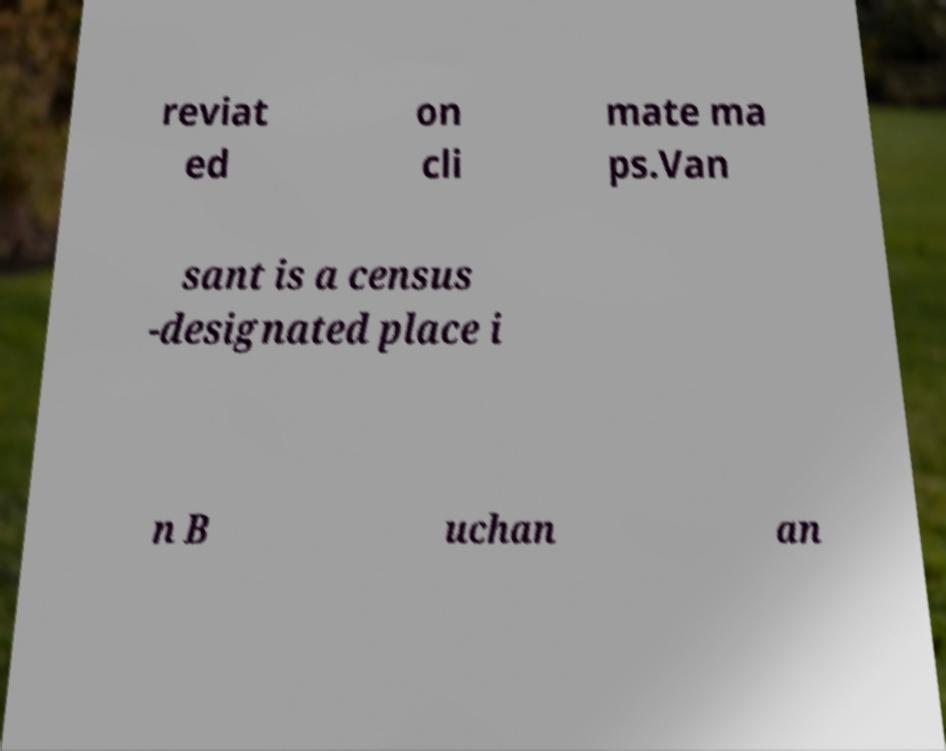Could you assist in decoding the text presented in this image and type it out clearly? reviat ed on cli mate ma ps.Van sant is a census -designated place i n B uchan an 